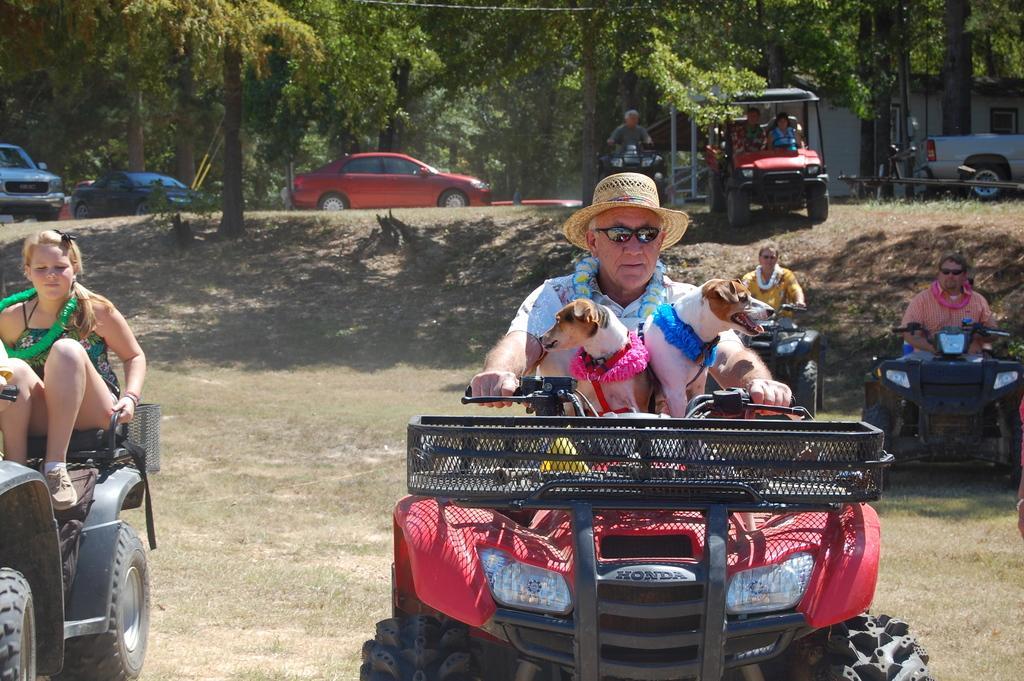Can you describe this image briefly? On the left side of the image we can see a lady is sitting on a bike and some cars are there. In the middle of the image we can see a person riding a bike. On the right side of the image we can see two persons are riding a bike. 